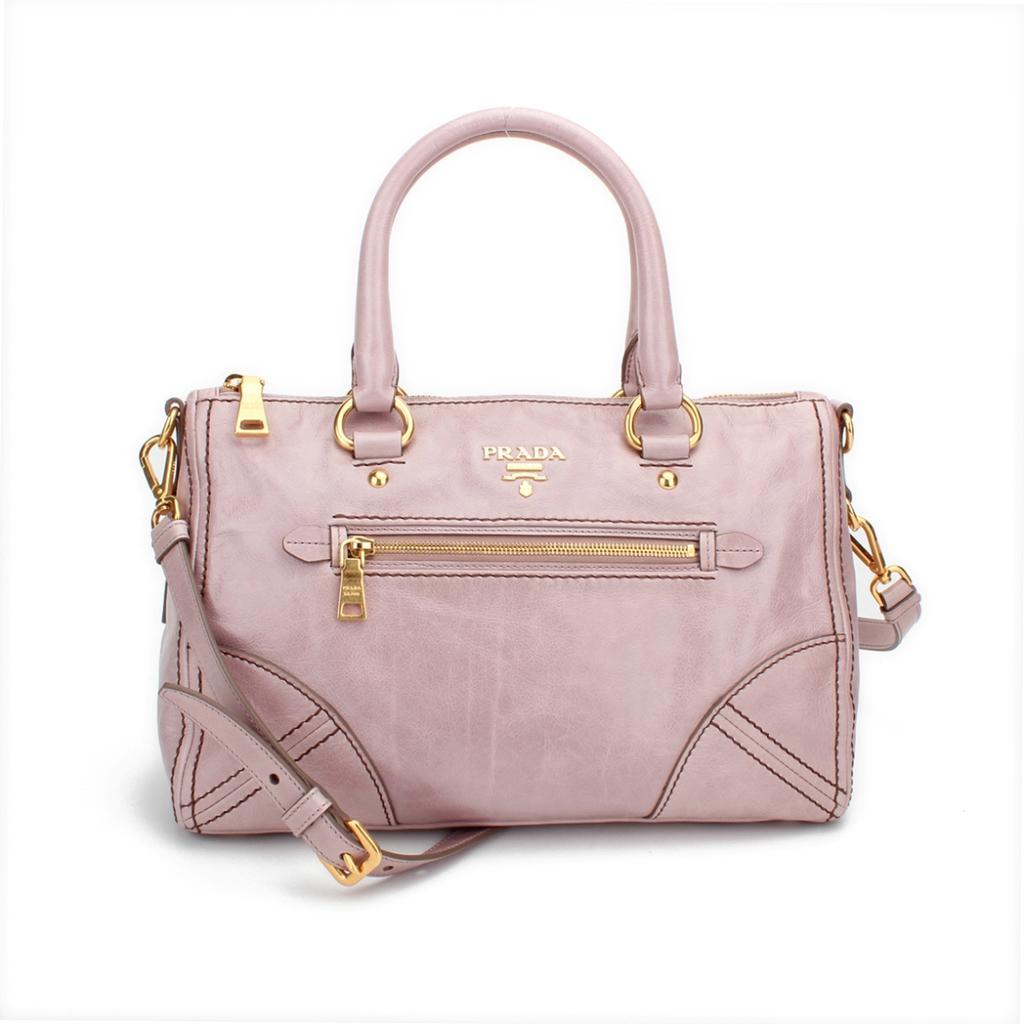How would you summarize this image in a sentence or two? In this image i can see a pink color handbag. 